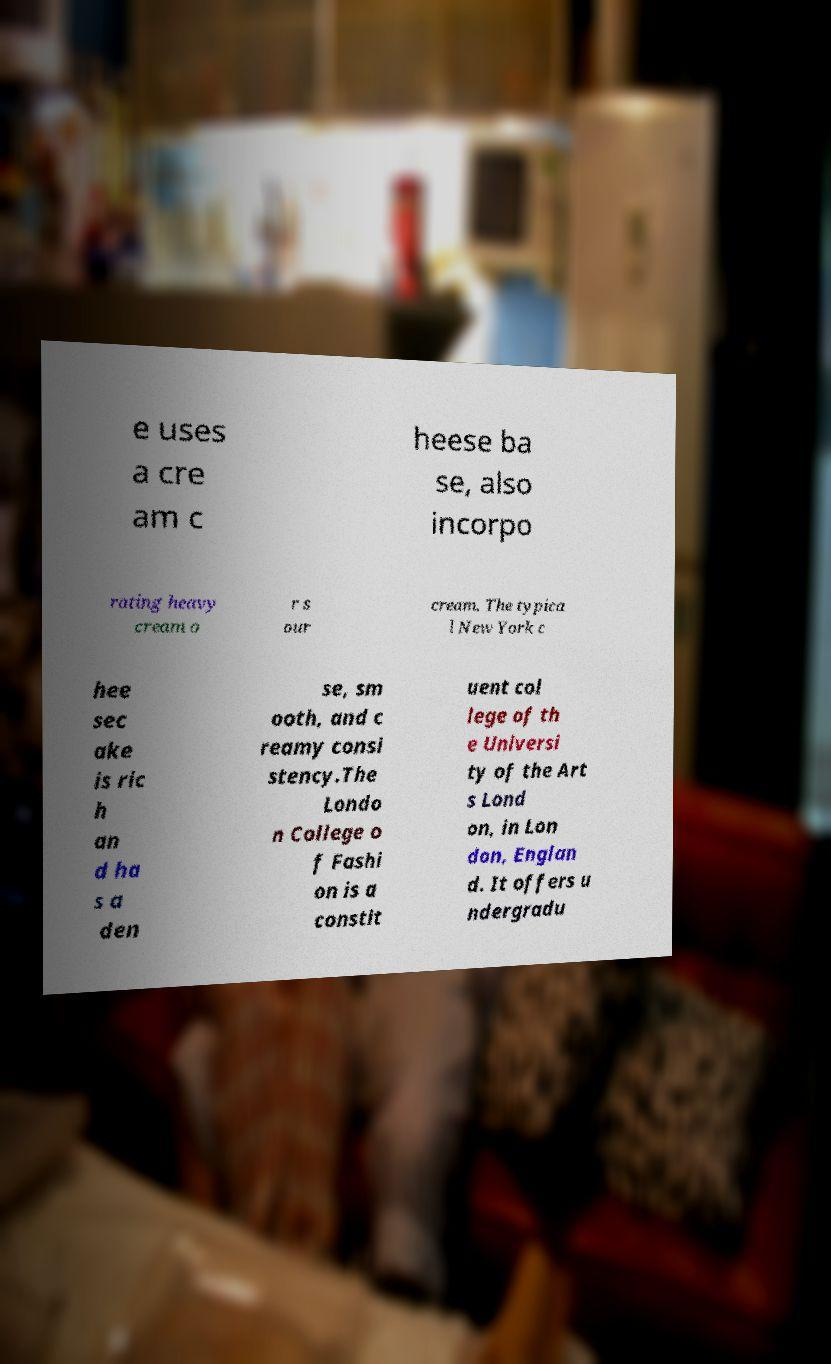For documentation purposes, I need the text within this image transcribed. Could you provide that? e uses a cre am c heese ba se, also incorpo rating heavy cream o r s our cream. The typica l New York c hee sec ake is ric h an d ha s a den se, sm ooth, and c reamy consi stency.The Londo n College o f Fashi on is a constit uent col lege of th e Universi ty of the Art s Lond on, in Lon don, Englan d. It offers u ndergradu 